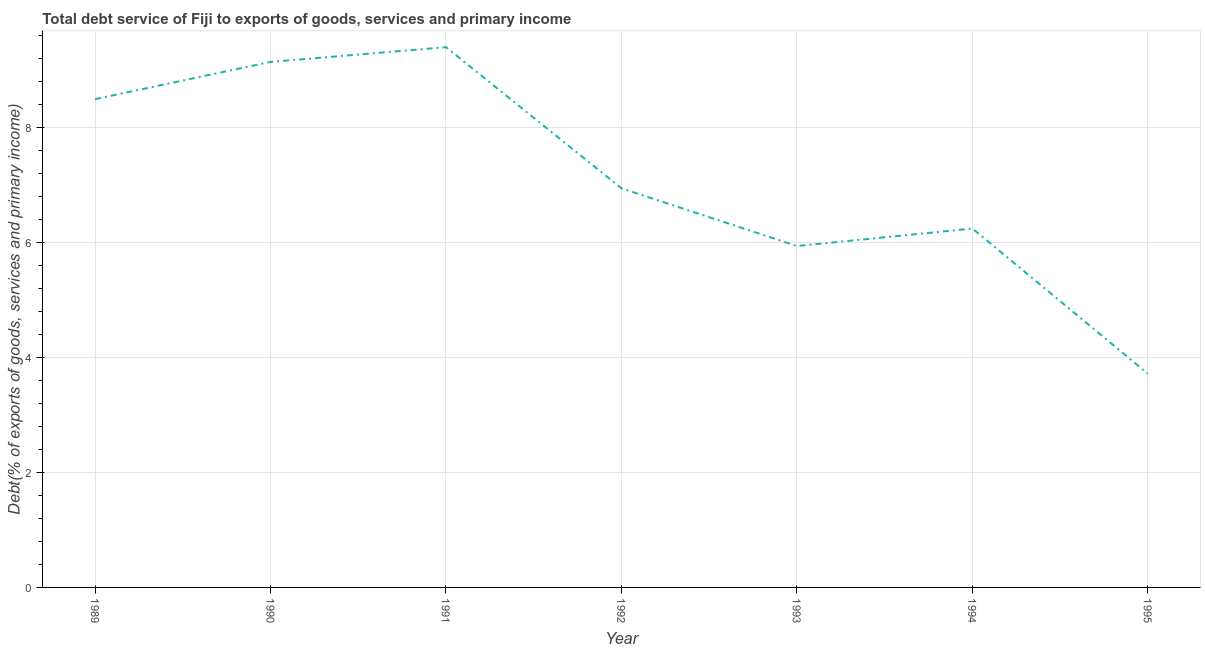What is the total debt service in 1994?
Your answer should be compact. 6.25. Across all years, what is the maximum total debt service?
Offer a terse response. 9.4. Across all years, what is the minimum total debt service?
Ensure brevity in your answer.  3.72. In which year was the total debt service minimum?
Make the answer very short. 1995. What is the sum of the total debt service?
Offer a terse response. 49.9. What is the difference between the total debt service in 1991 and 1993?
Offer a very short reply. 3.46. What is the average total debt service per year?
Provide a succinct answer. 7.13. What is the median total debt service?
Your response must be concise. 6.95. Do a majority of the years between 1993 and 1994 (inclusive) have total debt service greater than 0.4 %?
Your answer should be very brief. Yes. What is the ratio of the total debt service in 1992 to that in 1993?
Keep it short and to the point. 1.17. Is the total debt service in 1992 less than that in 1995?
Give a very brief answer. No. What is the difference between the highest and the second highest total debt service?
Your answer should be compact. 0.26. Is the sum of the total debt service in 1991 and 1992 greater than the maximum total debt service across all years?
Give a very brief answer. Yes. What is the difference between the highest and the lowest total debt service?
Provide a short and direct response. 5.68. How many lines are there?
Offer a terse response. 1. How many years are there in the graph?
Provide a succinct answer. 7. Does the graph contain any zero values?
Keep it short and to the point. No. Does the graph contain grids?
Your answer should be compact. Yes. What is the title of the graph?
Offer a terse response. Total debt service of Fiji to exports of goods, services and primary income. What is the label or title of the X-axis?
Provide a short and direct response. Year. What is the label or title of the Y-axis?
Ensure brevity in your answer.  Debt(% of exports of goods, services and primary income). What is the Debt(% of exports of goods, services and primary income) of 1989?
Offer a very short reply. 8.5. What is the Debt(% of exports of goods, services and primary income) of 1990?
Offer a very short reply. 9.15. What is the Debt(% of exports of goods, services and primary income) in 1991?
Your response must be concise. 9.4. What is the Debt(% of exports of goods, services and primary income) of 1992?
Offer a very short reply. 6.95. What is the Debt(% of exports of goods, services and primary income) of 1993?
Give a very brief answer. 5.94. What is the Debt(% of exports of goods, services and primary income) in 1994?
Keep it short and to the point. 6.25. What is the Debt(% of exports of goods, services and primary income) of 1995?
Offer a terse response. 3.72. What is the difference between the Debt(% of exports of goods, services and primary income) in 1989 and 1990?
Your answer should be very brief. -0.65. What is the difference between the Debt(% of exports of goods, services and primary income) in 1989 and 1991?
Offer a terse response. -0.9. What is the difference between the Debt(% of exports of goods, services and primary income) in 1989 and 1992?
Your response must be concise. 1.55. What is the difference between the Debt(% of exports of goods, services and primary income) in 1989 and 1993?
Keep it short and to the point. 2.56. What is the difference between the Debt(% of exports of goods, services and primary income) in 1989 and 1994?
Provide a short and direct response. 2.25. What is the difference between the Debt(% of exports of goods, services and primary income) in 1989 and 1995?
Provide a short and direct response. 4.78. What is the difference between the Debt(% of exports of goods, services and primary income) in 1990 and 1991?
Provide a short and direct response. -0.26. What is the difference between the Debt(% of exports of goods, services and primary income) in 1990 and 1992?
Provide a short and direct response. 2.2. What is the difference between the Debt(% of exports of goods, services and primary income) in 1990 and 1993?
Keep it short and to the point. 3.2. What is the difference between the Debt(% of exports of goods, services and primary income) in 1990 and 1994?
Offer a very short reply. 2.9. What is the difference between the Debt(% of exports of goods, services and primary income) in 1990 and 1995?
Provide a short and direct response. 5.43. What is the difference between the Debt(% of exports of goods, services and primary income) in 1991 and 1992?
Provide a succinct answer. 2.46. What is the difference between the Debt(% of exports of goods, services and primary income) in 1991 and 1993?
Provide a short and direct response. 3.46. What is the difference between the Debt(% of exports of goods, services and primary income) in 1991 and 1994?
Give a very brief answer. 3.16. What is the difference between the Debt(% of exports of goods, services and primary income) in 1991 and 1995?
Offer a very short reply. 5.68. What is the difference between the Debt(% of exports of goods, services and primary income) in 1992 and 1993?
Your answer should be compact. 1. What is the difference between the Debt(% of exports of goods, services and primary income) in 1992 and 1994?
Provide a short and direct response. 0.7. What is the difference between the Debt(% of exports of goods, services and primary income) in 1992 and 1995?
Your answer should be compact. 3.23. What is the difference between the Debt(% of exports of goods, services and primary income) in 1993 and 1994?
Offer a terse response. -0.3. What is the difference between the Debt(% of exports of goods, services and primary income) in 1993 and 1995?
Keep it short and to the point. 2.22. What is the difference between the Debt(% of exports of goods, services and primary income) in 1994 and 1995?
Your response must be concise. 2.53. What is the ratio of the Debt(% of exports of goods, services and primary income) in 1989 to that in 1990?
Provide a short and direct response. 0.93. What is the ratio of the Debt(% of exports of goods, services and primary income) in 1989 to that in 1991?
Provide a succinct answer. 0.9. What is the ratio of the Debt(% of exports of goods, services and primary income) in 1989 to that in 1992?
Make the answer very short. 1.22. What is the ratio of the Debt(% of exports of goods, services and primary income) in 1989 to that in 1993?
Your answer should be very brief. 1.43. What is the ratio of the Debt(% of exports of goods, services and primary income) in 1989 to that in 1994?
Keep it short and to the point. 1.36. What is the ratio of the Debt(% of exports of goods, services and primary income) in 1989 to that in 1995?
Provide a short and direct response. 2.29. What is the ratio of the Debt(% of exports of goods, services and primary income) in 1990 to that in 1991?
Give a very brief answer. 0.97. What is the ratio of the Debt(% of exports of goods, services and primary income) in 1990 to that in 1992?
Your answer should be very brief. 1.32. What is the ratio of the Debt(% of exports of goods, services and primary income) in 1990 to that in 1993?
Provide a short and direct response. 1.54. What is the ratio of the Debt(% of exports of goods, services and primary income) in 1990 to that in 1994?
Offer a terse response. 1.46. What is the ratio of the Debt(% of exports of goods, services and primary income) in 1990 to that in 1995?
Give a very brief answer. 2.46. What is the ratio of the Debt(% of exports of goods, services and primary income) in 1991 to that in 1992?
Offer a terse response. 1.35. What is the ratio of the Debt(% of exports of goods, services and primary income) in 1991 to that in 1993?
Ensure brevity in your answer.  1.58. What is the ratio of the Debt(% of exports of goods, services and primary income) in 1991 to that in 1994?
Offer a very short reply. 1.5. What is the ratio of the Debt(% of exports of goods, services and primary income) in 1991 to that in 1995?
Provide a succinct answer. 2.53. What is the ratio of the Debt(% of exports of goods, services and primary income) in 1992 to that in 1993?
Offer a terse response. 1.17. What is the ratio of the Debt(% of exports of goods, services and primary income) in 1992 to that in 1994?
Ensure brevity in your answer.  1.11. What is the ratio of the Debt(% of exports of goods, services and primary income) in 1992 to that in 1995?
Your response must be concise. 1.87. What is the ratio of the Debt(% of exports of goods, services and primary income) in 1993 to that in 1994?
Provide a succinct answer. 0.95. What is the ratio of the Debt(% of exports of goods, services and primary income) in 1993 to that in 1995?
Your answer should be compact. 1.6. What is the ratio of the Debt(% of exports of goods, services and primary income) in 1994 to that in 1995?
Offer a very short reply. 1.68. 